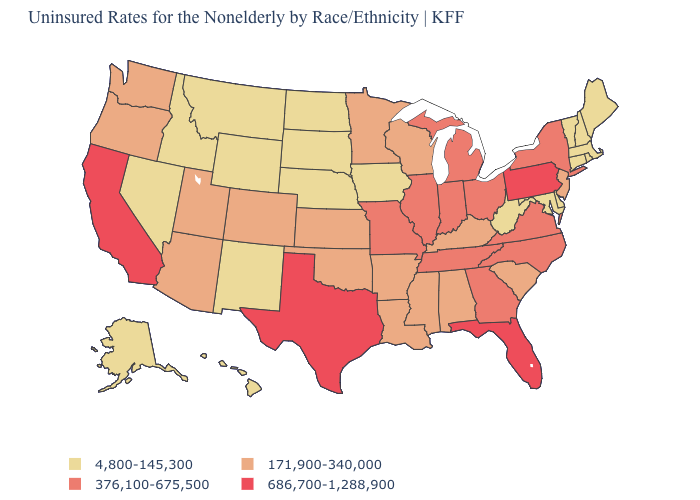Which states hav the highest value in the South?
Be succinct. Florida, Texas. Name the states that have a value in the range 171,900-340,000?
Be succinct. Alabama, Arizona, Arkansas, Colorado, Kansas, Kentucky, Louisiana, Minnesota, Mississippi, New Jersey, Oklahoma, Oregon, South Carolina, Utah, Washington, Wisconsin. What is the value of Virginia?
Answer briefly. 376,100-675,500. Which states hav the highest value in the South?
Concise answer only. Florida, Texas. What is the value of Montana?
Quick response, please. 4,800-145,300. What is the lowest value in states that border Utah?
Answer briefly. 4,800-145,300. Name the states that have a value in the range 4,800-145,300?
Be succinct. Alaska, Connecticut, Delaware, Hawaii, Idaho, Iowa, Maine, Maryland, Massachusetts, Montana, Nebraska, Nevada, New Hampshire, New Mexico, North Dakota, Rhode Island, South Dakota, Vermont, West Virginia, Wyoming. What is the value of Alaska?
Quick response, please. 4,800-145,300. What is the lowest value in the USA?
Keep it brief. 4,800-145,300. Name the states that have a value in the range 686,700-1,288,900?
Give a very brief answer. California, Florida, Pennsylvania, Texas. Name the states that have a value in the range 376,100-675,500?
Give a very brief answer. Georgia, Illinois, Indiana, Michigan, Missouri, New York, North Carolina, Ohio, Tennessee, Virginia. Does Kentucky have the same value as Oklahoma?
Quick response, please. Yes. What is the value of California?
Short answer required. 686,700-1,288,900. What is the highest value in the Northeast ?
Write a very short answer. 686,700-1,288,900. What is the lowest value in states that border Maryland?
Keep it brief. 4,800-145,300. 